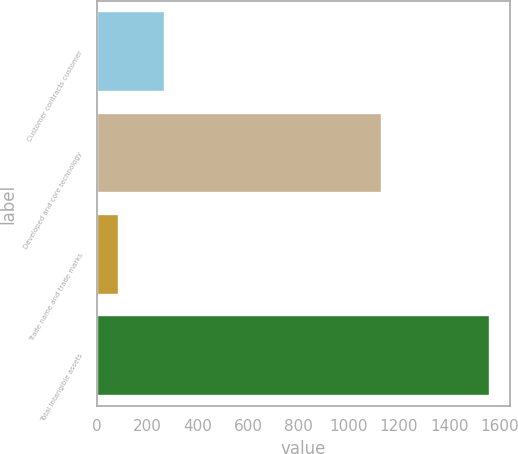<chart> <loc_0><loc_0><loc_500><loc_500><bar_chart><fcel>Customer contracts customer<fcel>Developed and core technology<fcel>Trade name and trade marks<fcel>Total intangible assets<nl><fcel>268<fcel>1133<fcel>87<fcel>1563<nl></chart> 